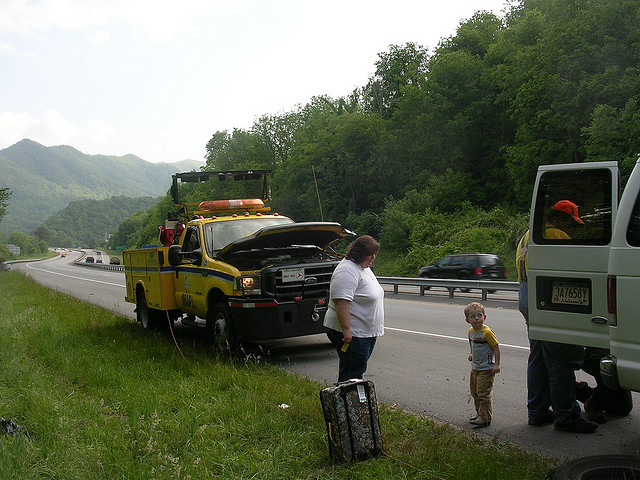Please identify all text content in this image. 3A7658Y 